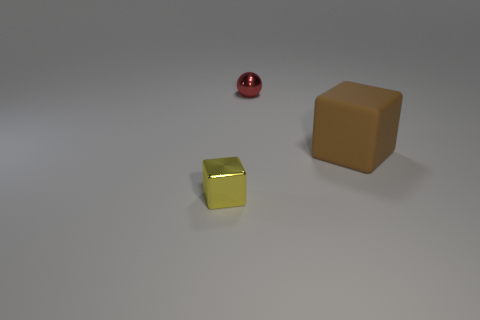Subtract all brown blocks. Subtract all purple cylinders. How many blocks are left? 1 Add 1 tiny balls. How many objects exist? 4 Subtract all blocks. How many objects are left? 1 Add 3 tiny yellow rubber cylinders. How many tiny yellow rubber cylinders exist? 3 Subtract 0 green cylinders. How many objects are left? 3 Subtract all large cyan shiny cylinders. Subtract all shiny cubes. How many objects are left? 2 Add 3 big brown cubes. How many big brown cubes are left? 4 